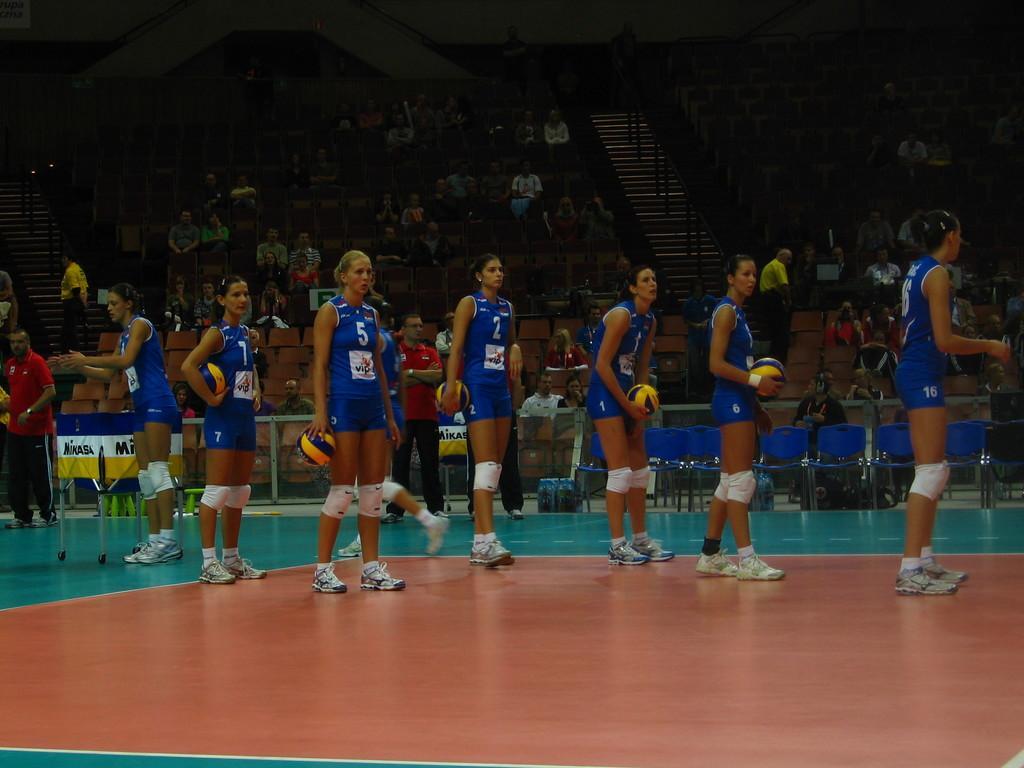How would you summarize this image in a sentence or two? In the picture we can see some women players are standing on the floor holding a volleyball and wearing a blue sports wear and in the background, we can see chairs and the audience sitting on it and we can see some steps and railing near it. 